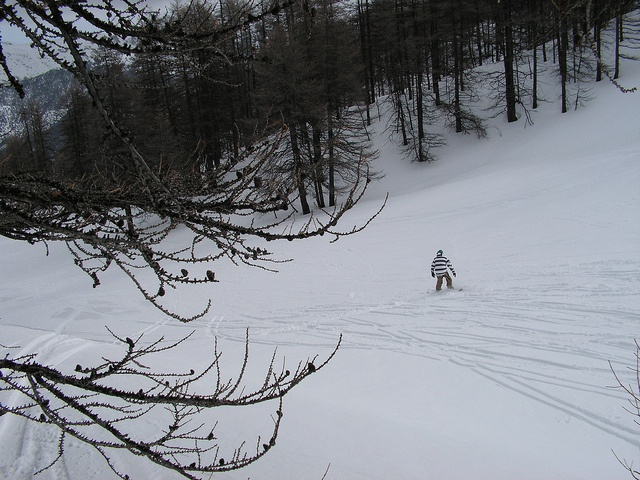Describe the objects in this image and their specific colors. I can see people in black, gray, and darkgray tones, snowboard in black, darkgray, gray, and lightgray tones, and skis in black, darkgray, and gray tones in this image. 